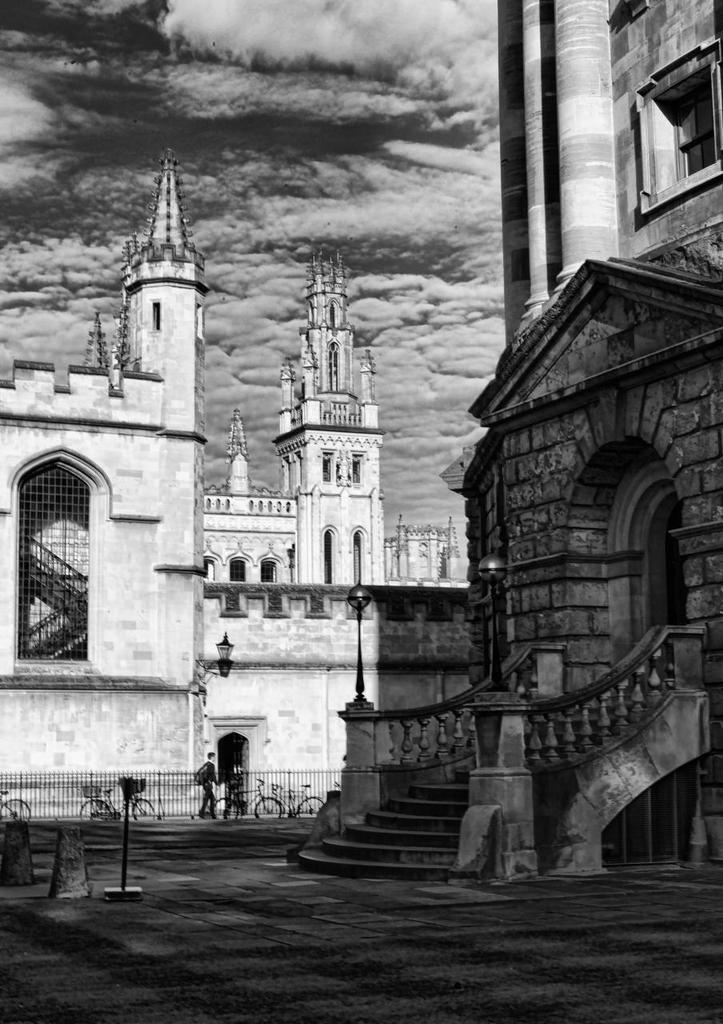What can be seen in the center of the image? The sky is visible in the center of the image. What is present in the sky? Clouds are present in the image. What type of structures can be seen in the image? There are buildings in the image. What mode of transportation is visible in the image? Cycles are present in the image. Are there any people in the image? Yes, there is at least one person in the image. What other objects can be seen in the image? There are a few other objects in the image. What type of leather is being used to make the reaction in the image? There is no leather or reaction present in the image. 